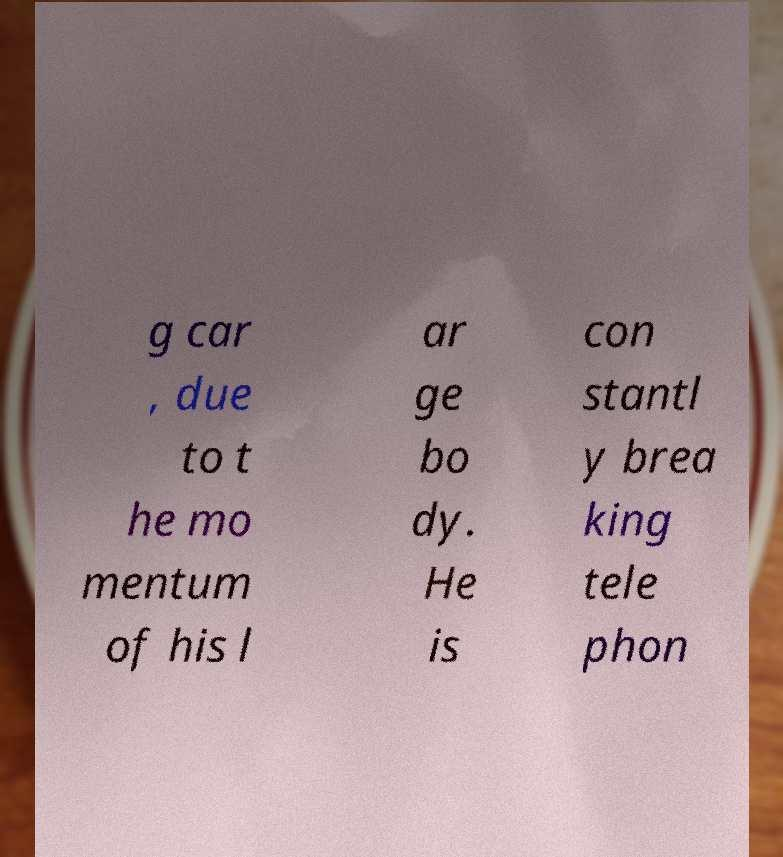Please read and relay the text visible in this image. What does it say? g car , due to t he mo mentum of his l ar ge bo dy. He is con stantl y brea king tele phon 